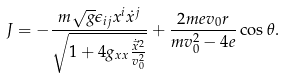<formula> <loc_0><loc_0><loc_500><loc_500>J = - \frac { m \sqrt { g } \epsilon _ { i j } x ^ { i } \dot { x } ^ { j } } { \sqrt { 1 + 4 g _ { x x } \frac { \dot { \vec { x } } ^ { 2 } } { v _ { 0 } ^ { 2 } } } } + \frac { 2 m e v _ { 0 } r } { m v _ { 0 } ^ { 2 } - 4 e } \cos \theta .</formula> 